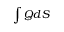<formula> <loc_0><loc_0><loc_500><loc_500>\int Q d S</formula> 